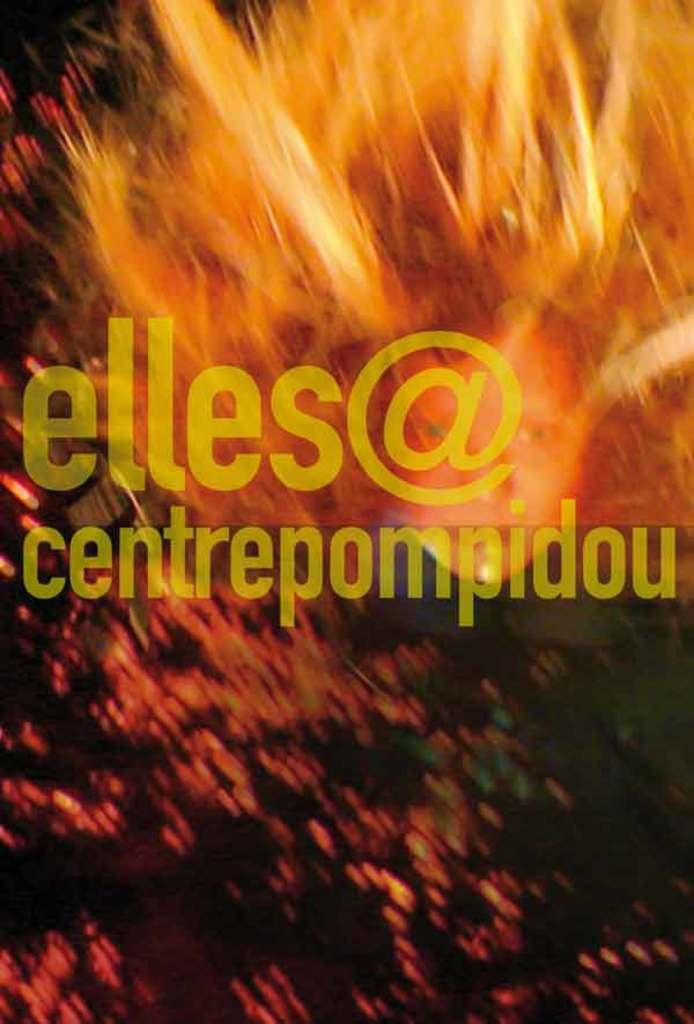<image>
Provide a brief description of the given image. a blurry photo that says elles@centrepompidou on it 